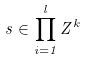Convert formula to latex. <formula><loc_0><loc_0><loc_500><loc_500>s \in \prod _ { i = 1 } ^ { l } Z ^ { k }</formula> 